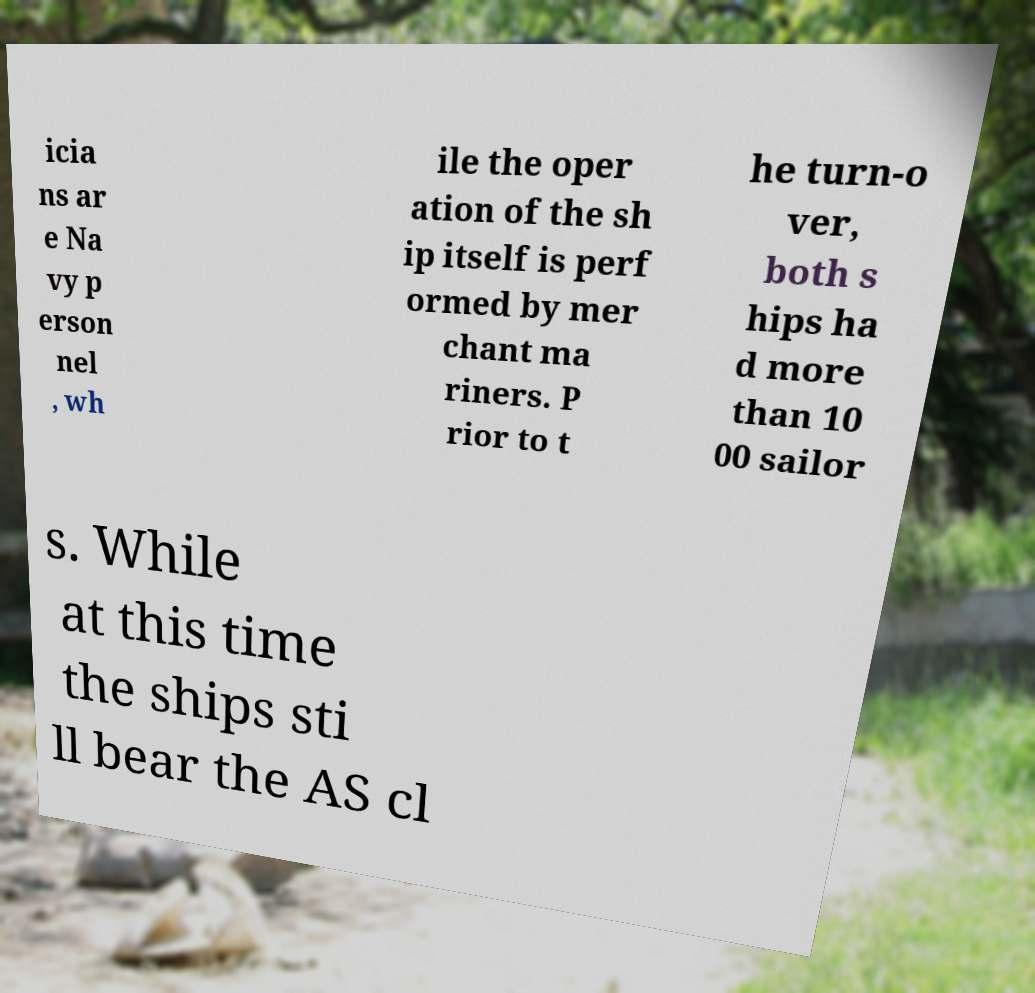There's text embedded in this image that I need extracted. Can you transcribe it verbatim? icia ns ar e Na vy p erson nel , wh ile the oper ation of the sh ip itself is perf ormed by mer chant ma riners. P rior to t he turn-o ver, both s hips ha d more than 10 00 sailor s. While at this time the ships sti ll bear the AS cl 